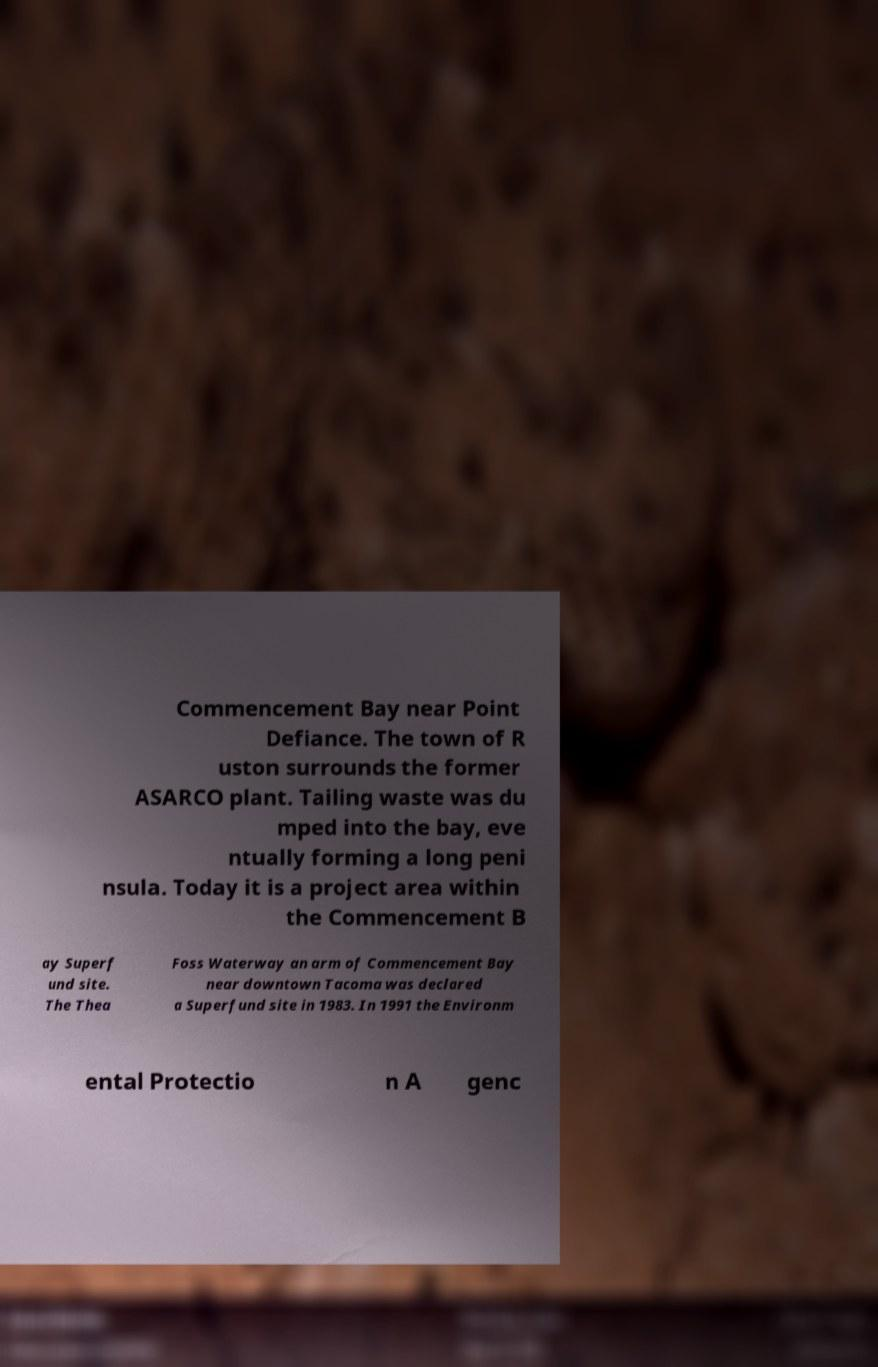For documentation purposes, I need the text within this image transcribed. Could you provide that? Commencement Bay near Point Defiance. The town of R uston surrounds the former ASARCO plant. Tailing waste was du mped into the bay, eve ntually forming a long peni nsula. Today it is a project area within the Commencement B ay Superf und site. The Thea Foss Waterway an arm of Commencement Bay near downtown Tacoma was declared a Superfund site in 1983. In 1991 the Environm ental Protectio n A genc 